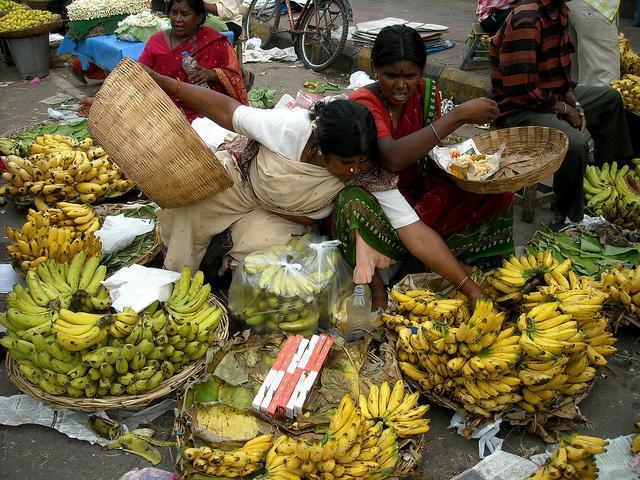How many bananas are in the photo?
Give a very brief answer. 5. How many people are visible?
Give a very brief answer. 5. How many bicycles are in the photo?
Give a very brief answer. 1. How many skateboards are tipped up?
Give a very brief answer. 0. 